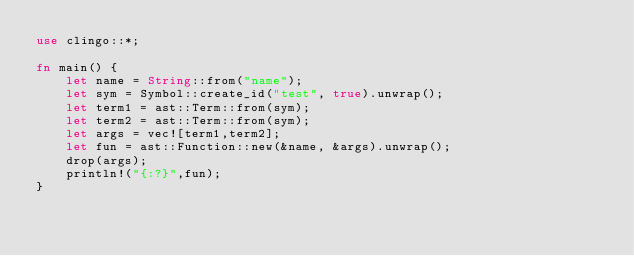<code> <loc_0><loc_0><loc_500><loc_500><_Rust_>use clingo::*;

fn main() {
    let name = String::from("name");
    let sym = Symbol::create_id("test", true).unwrap();
    let term1 = ast::Term::from(sym);
    let term2 = ast::Term::from(sym);
    let args = vec![term1,term2];
    let fun = ast::Function::new(&name, &args).unwrap();
    drop(args);
    println!("{:?}",fun);
}</code> 